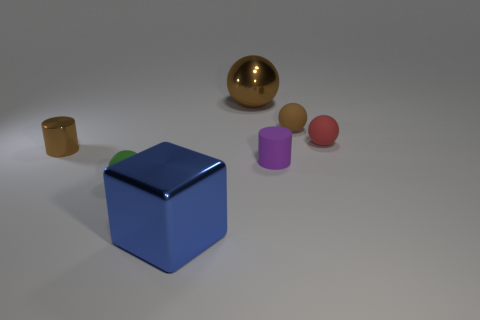Subtract all red balls. How many balls are left? 3 Subtract all brown metal spheres. How many spheres are left? 3 Subtract all gray spheres. Subtract all blue cylinders. How many spheres are left? 4 Add 2 large cyan blocks. How many objects exist? 9 Subtract 0 blue balls. How many objects are left? 7 Subtract all spheres. How many objects are left? 3 Subtract all purple things. Subtract all large purple rubber blocks. How many objects are left? 6 Add 3 large brown metallic balls. How many large brown metallic balls are left? 4 Add 7 green matte things. How many green matte things exist? 8 